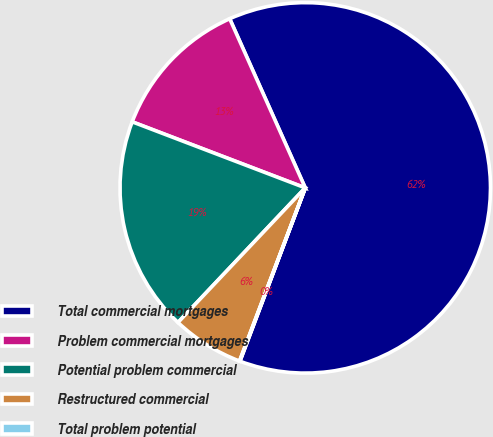Convert chart. <chart><loc_0><loc_0><loc_500><loc_500><pie_chart><fcel>Total commercial mortgages<fcel>Problem commercial mortgages<fcel>Potential problem commercial<fcel>Restructured commercial<fcel>Total problem potential<nl><fcel>62.42%<fcel>12.51%<fcel>18.75%<fcel>6.28%<fcel>0.04%<nl></chart> 